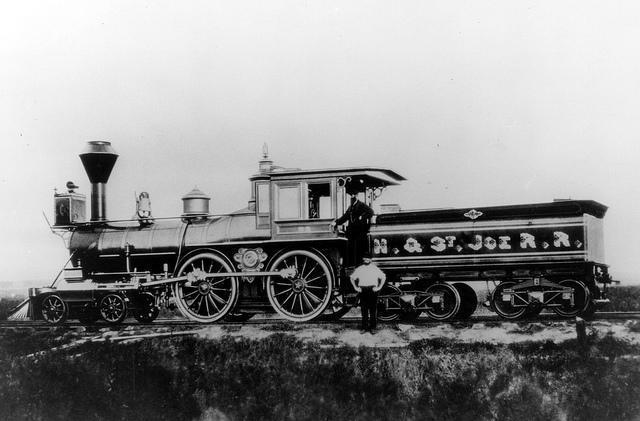How many people are in the picture?
Give a very brief answer. 2. How many colors are in the picture?
Give a very brief answer. 2. 